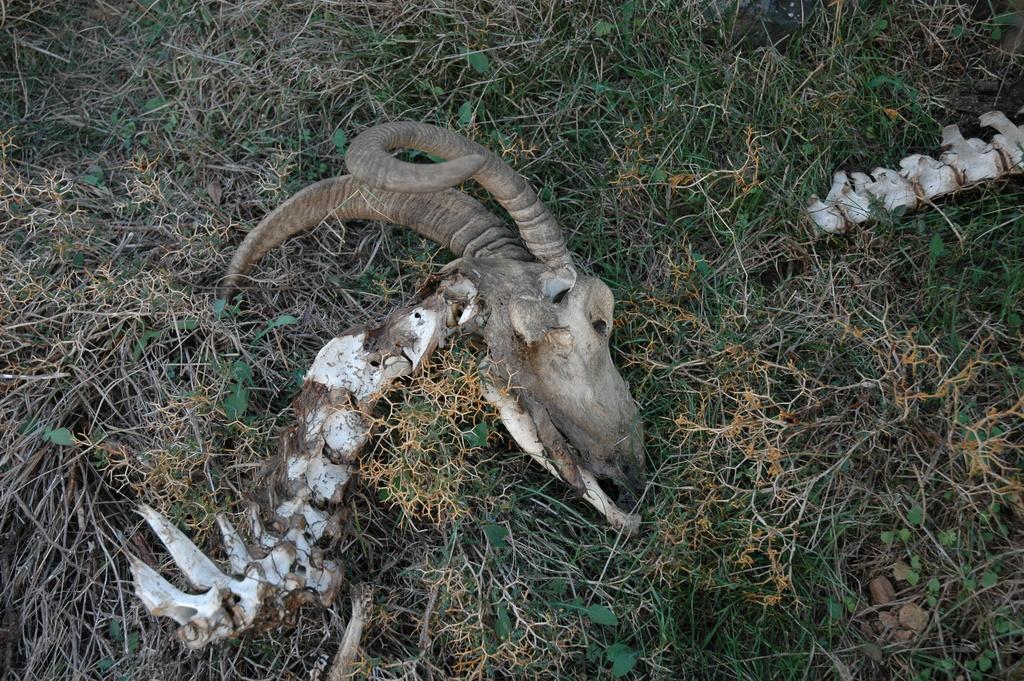How would you summarize this image in a sentence or two? In this image we can see an animal head on the grass. 